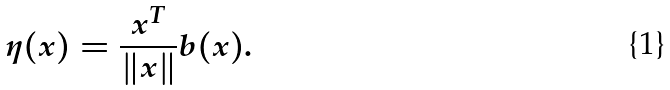<formula> <loc_0><loc_0><loc_500><loc_500>\eta ( x ) = \frac { x ^ { T } } { \| x \| } b ( x ) .</formula> 